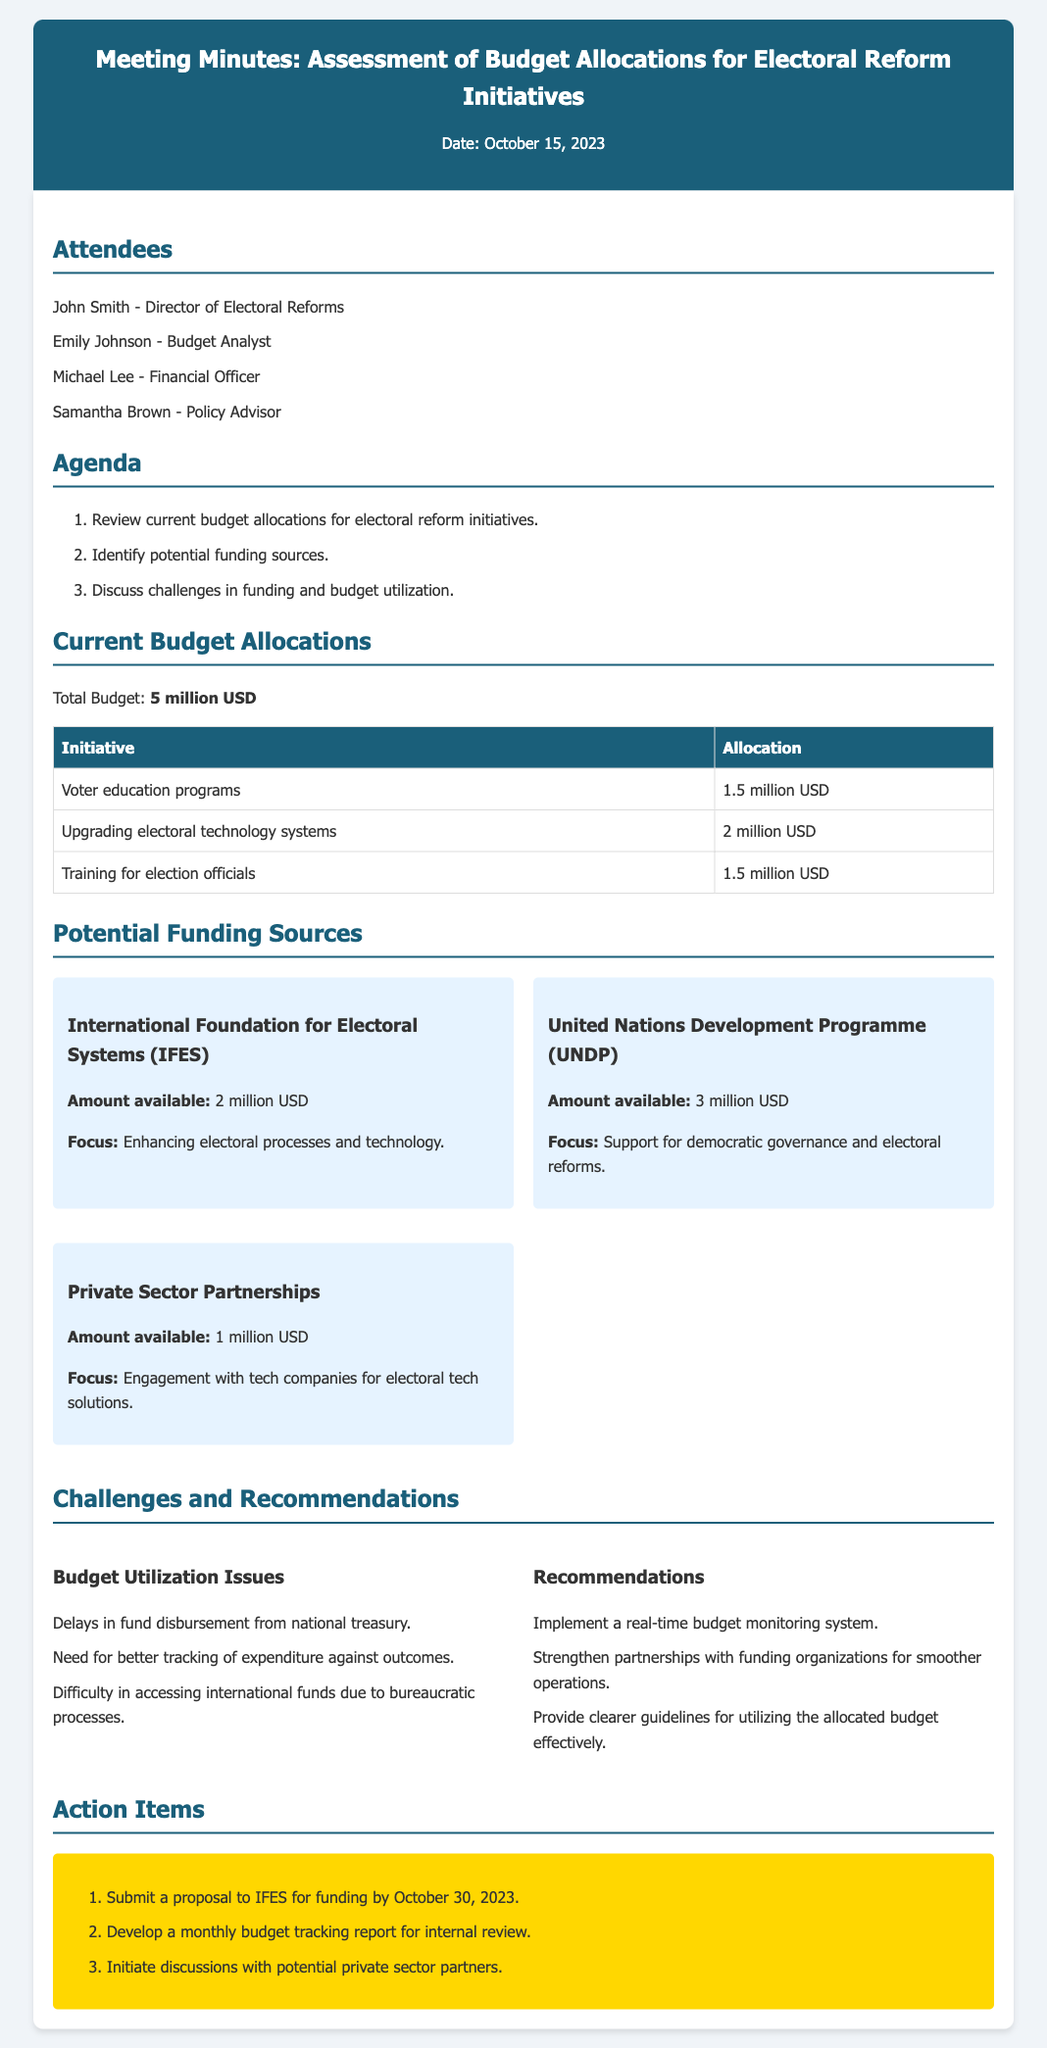What is the date of the meeting? The date of the meeting is specified in the header of the document.
Answer: October 15, 2023 Who is the Financial Officer? The document lists the attendees, including their roles.
Answer: Michael Lee What is the total budget allocated for electoral reform initiatives? The total budget is outlined in the section about current budget allocations.
Answer: 5 million USD How much is allocated for voter education programs? The amount allocated for voter education programs is found in the budget allocations table.
Answer: 1.5 million USD What are the three potential funding sources mentioned? The funding sources are mentioned in a grid format, naming each source.
Answer: IFES, UNDP, Private Sector Partnerships What is one challenge noted in the document regarding budget utilization? The challenges are listed and detailed in the challenges section of the document.
Answer: Delays in fund disbursement from national treasury What recommendation is proposed for budget utilization? The recommendations are provided under the challenges section for improving budget usage.
Answer: Implement a real-time budget monitoring system When is the proposal to IFES due? The action items detail the deadlines for proposals.
Answer: October 30, 2023 